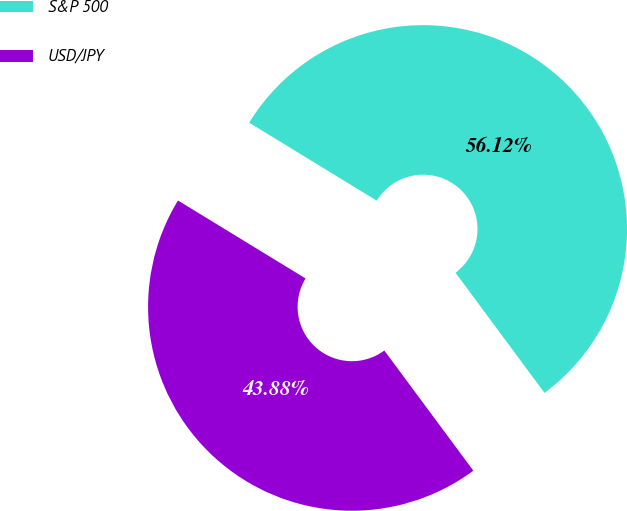Convert chart. <chart><loc_0><loc_0><loc_500><loc_500><pie_chart><fcel>S&P 500<fcel>USD/JPY<nl><fcel>56.12%<fcel>43.88%<nl></chart> 